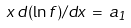<formula> <loc_0><loc_0><loc_500><loc_500>x \, d ( \ln f ) / d x \, = \, a _ { 1 }</formula> 